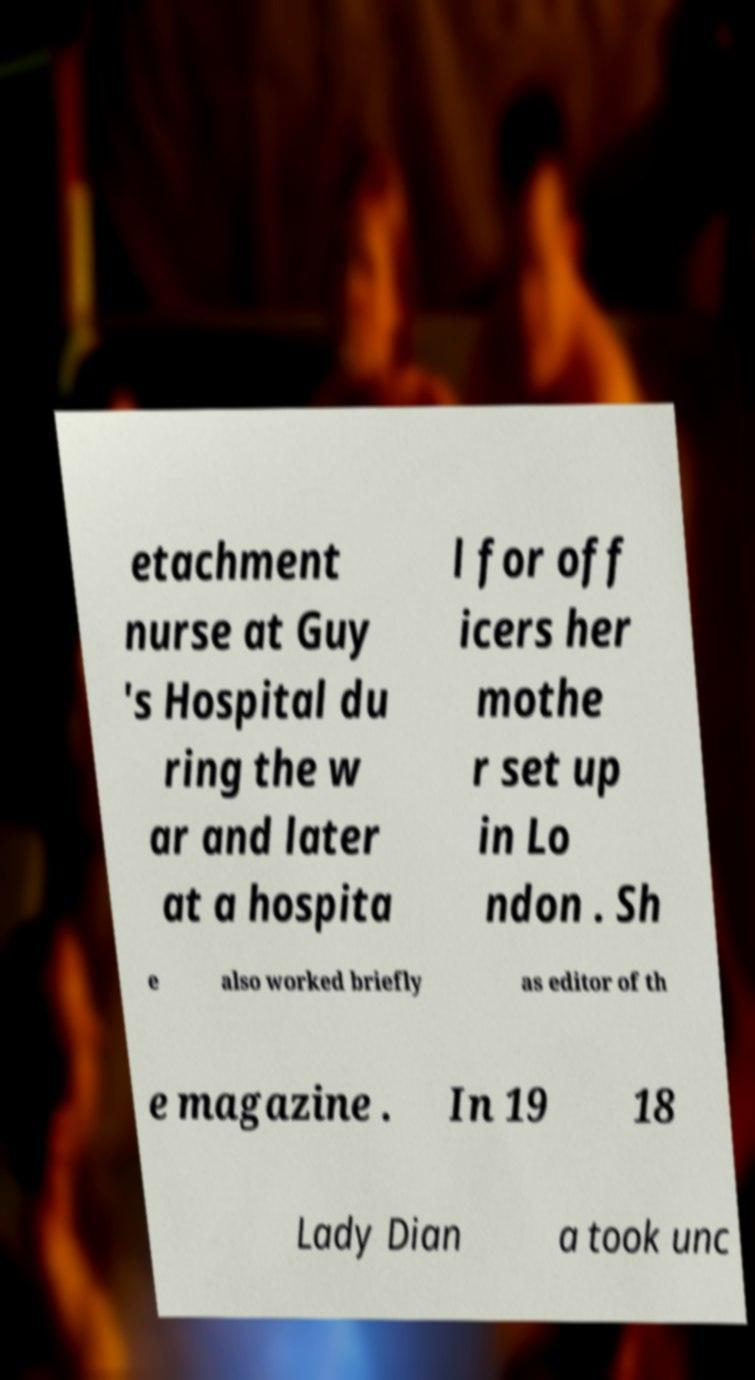For documentation purposes, I need the text within this image transcribed. Could you provide that? etachment nurse at Guy 's Hospital du ring the w ar and later at a hospita l for off icers her mothe r set up in Lo ndon . Sh e also worked briefly as editor of th e magazine . In 19 18 Lady Dian a took unc 